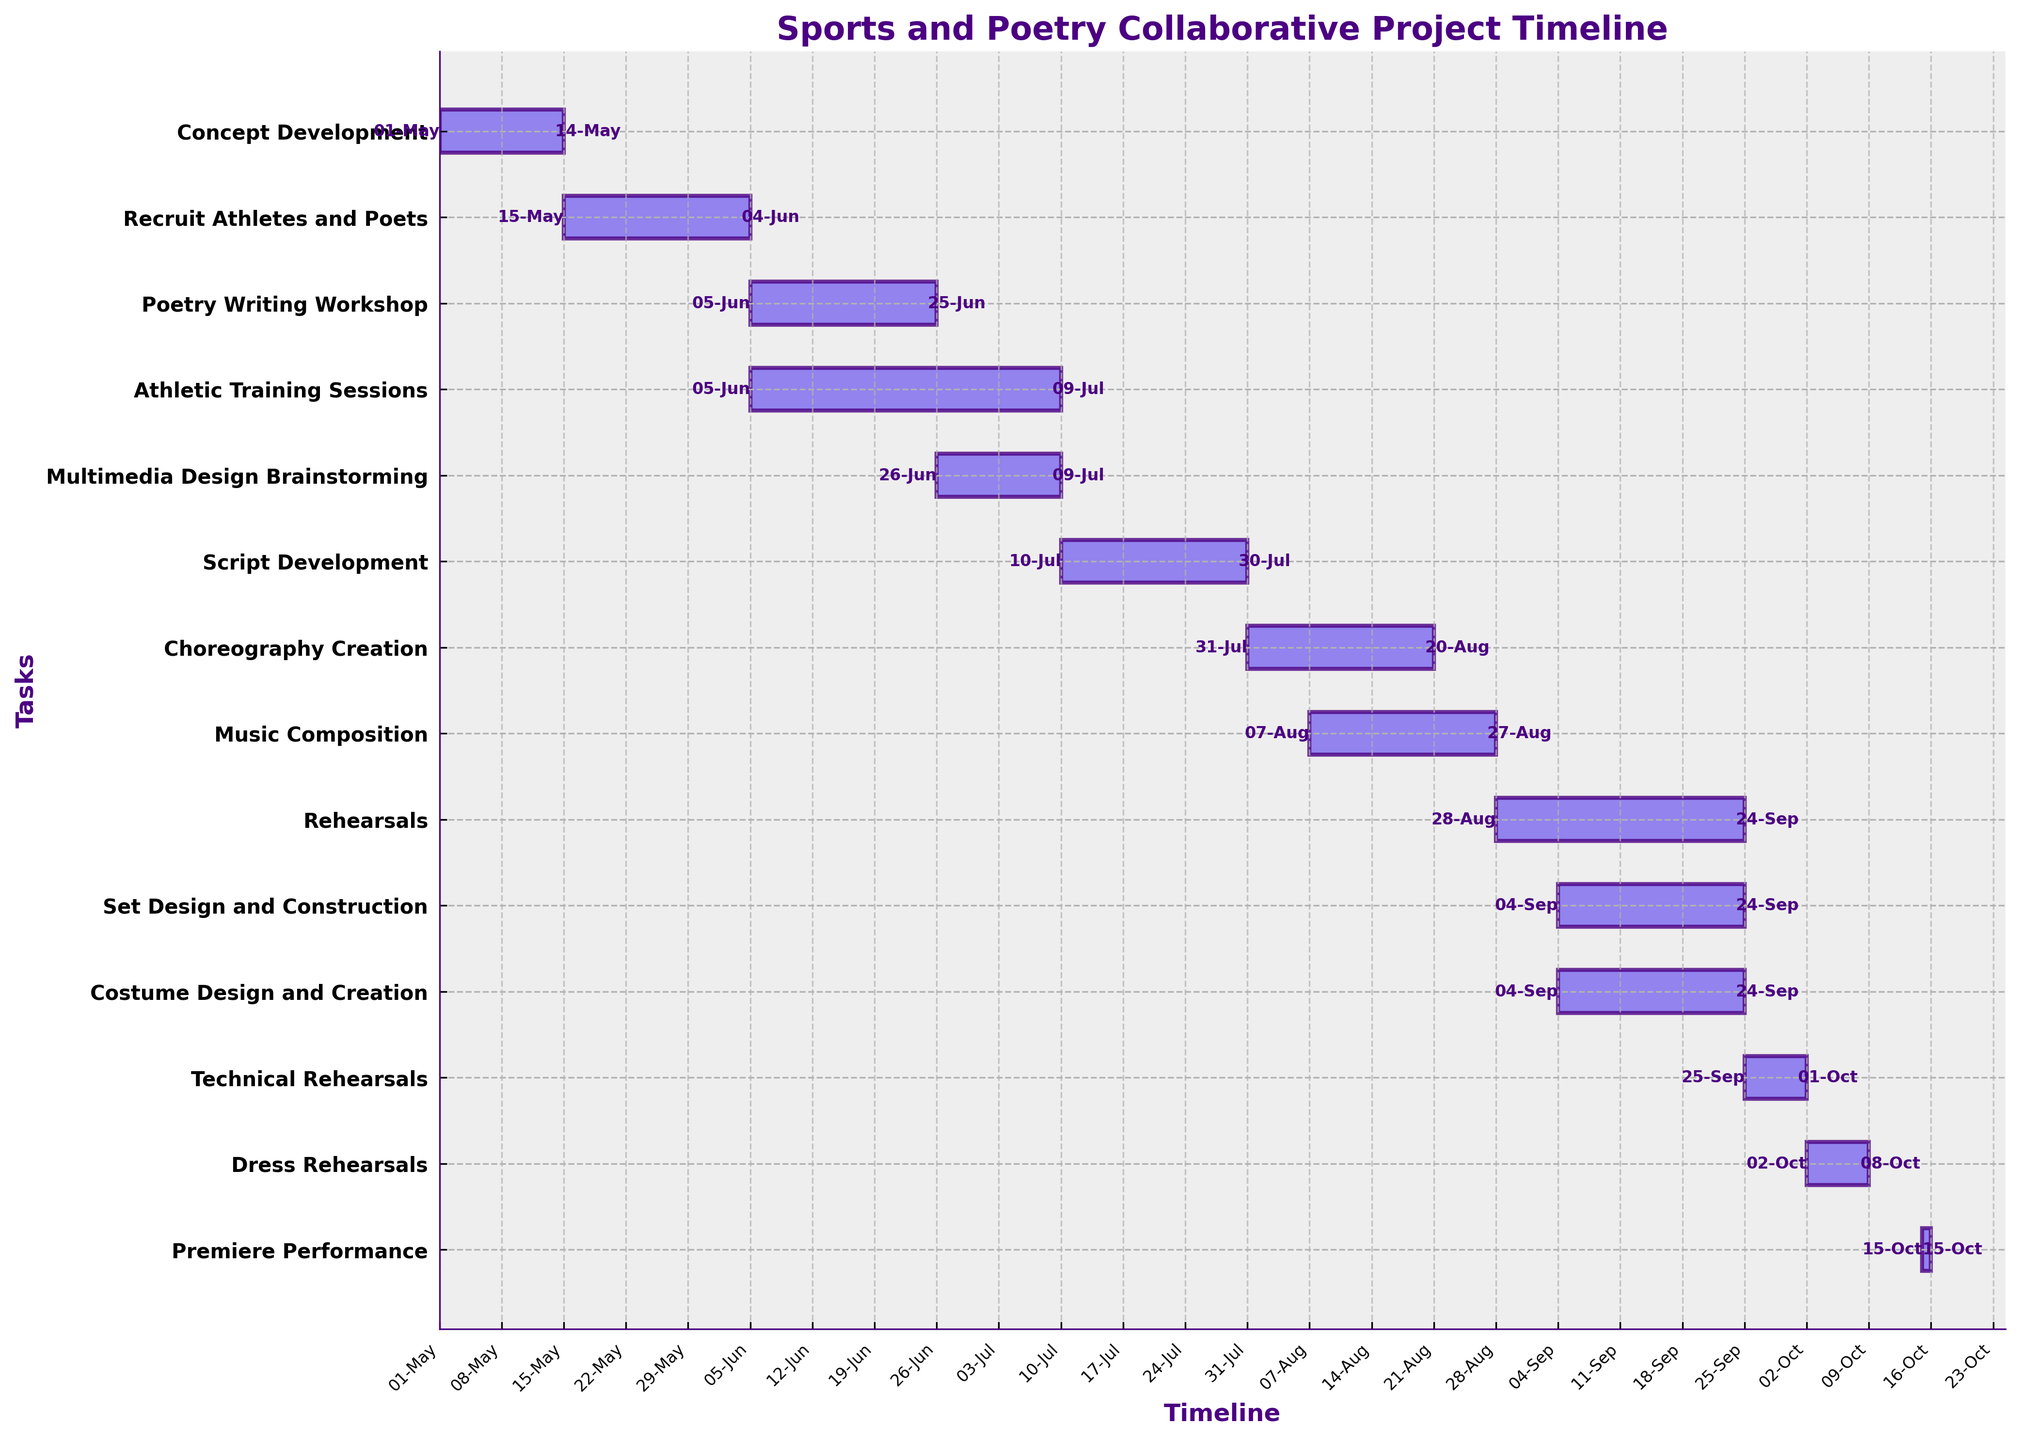What is the first task listed in the project timeline? The first task listed in the project timeline is "Concept Development". This is identified by looking at the top-most task on the y-axis.
Answer: Concept Development When does the "Rehearsals" task start? The "Rehearsals" task starts on August 28, 2023. This can be determined by looking at the left edge of the task bar corresponding to "Rehearsals".
Answer: August 28, 2023 Which task has the longest duration and what is its duration? The "Athletic Training Sessions" task has the longest duration at 35 days. This conclusion is drawn by comparing the lengths of the task bars visually.
Answer: Athletic Training Sessions, 35 days How long does the "Costume Design and Creation" task take? The "Costume Design and Creation" task takes 21 days. This is indicated by looking at the length of the task bar corresponding to "Costume Design and Creation".
Answer: 21 days Which tasks are performed simultaneously during the period from September 4, 2023, to September 24, 2023? During this period, "Set Design and Construction", "Costume Design and Creation", and "Rehearsals" tasks are performed simultaneously. This is determined by observing the overlapping bars on the horizontal axis for the given period.
Answer: Set Design and Construction, Costume Design and Creation, Rehearsals How many days are there between the end of the "Technical Rehearsals" and the "Premiere Performance"? There are 14 days between the end of the "Technical Rehearsals" (October 1, 2023) and the "Premiere Performance" (October 15, 2023). Count the days between the end date of the "Technical Rehearsals" and the start date of the "Premiere Performance".
Answer: 14 days What are the start and end dates of the "Script Development" task? The "Script Development" task starts on July 10, 2023, and ends on July 30, 2023. These dates are written at the start and end points of the corresponding task bar.
Answer: July 10, 2023, and July 30, 2023 During which months does the "Poetry Writing Workshop" take place? The "Poetry Writing Workshop" takes place in June 2023. This is observed from the start and end dates of the task bar corresponding to this task.
Answer: June 2023 What task follows immediately after "Multimedia Design Brainstorming"? The task that follows immediately after "Multimedia Design Brainstorming" is "Script Development". This can be seen directly below "Multimedia Design Brainstorming" on the y-axis, indicating the sequence.
Answer: Script Development 